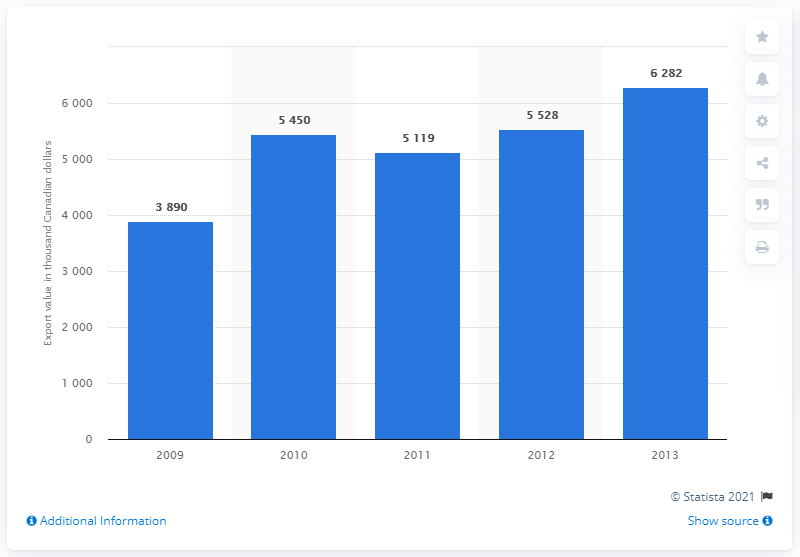Indicate a few pertinent items in this graphic. The value of maple sugar and maple syrup exports from Denmark increased in 2009. 